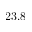<formula> <loc_0><loc_0><loc_500><loc_500>2 3 . 8</formula> 